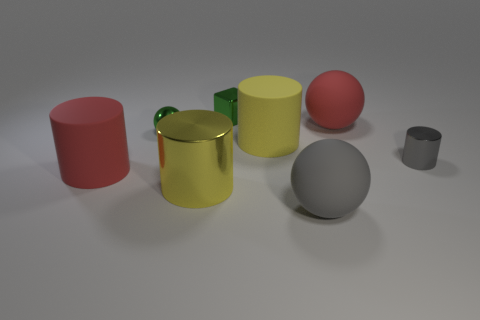Subtract all big cylinders. How many cylinders are left? 1 Subtract all gray cylinders. How many cylinders are left? 3 Add 1 red matte spheres. How many objects exist? 9 Subtract 2 cylinders. How many cylinders are left? 2 Subtract all balls. How many objects are left? 5 Subtract all gray cylinders. Subtract all yellow balls. How many cylinders are left? 3 Subtract all purple cylinders. How many red cubes are left? 0 Subtract all yellow metal cylinders. Subtract all small metallic cylinders. How many objects are left? 6 Add 3 gray balls. How many gray balls are left? 4 Add 6 tiny green metal blocks. How many tiny green metal blocks exist? 7 